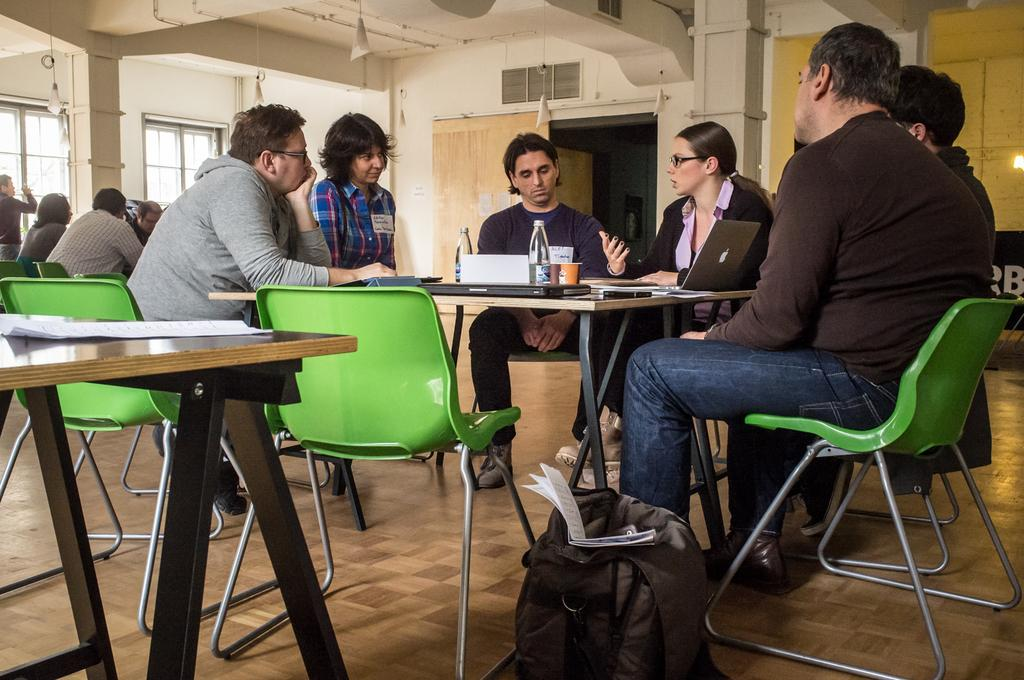What are the people in the image doing? The people in the image are sitting on chairs. What can be seen on the table in the image? There is a cup, a bottle, and other objects on the table in the image. What is the man in the image doing? There is a man standing in the image. What items can be seen in the image related to reading or carrying items? There is a bag and a book in the image. What type of fear can be seen on the jellyfish in the image? There are no jellyfish present in the image; it features people sitting on chairs, a table with objects, a standing man, a bag, and a book. What reward is given to the person who completes the task in the image? There is no task or reward mentioned or depicted in the image. 